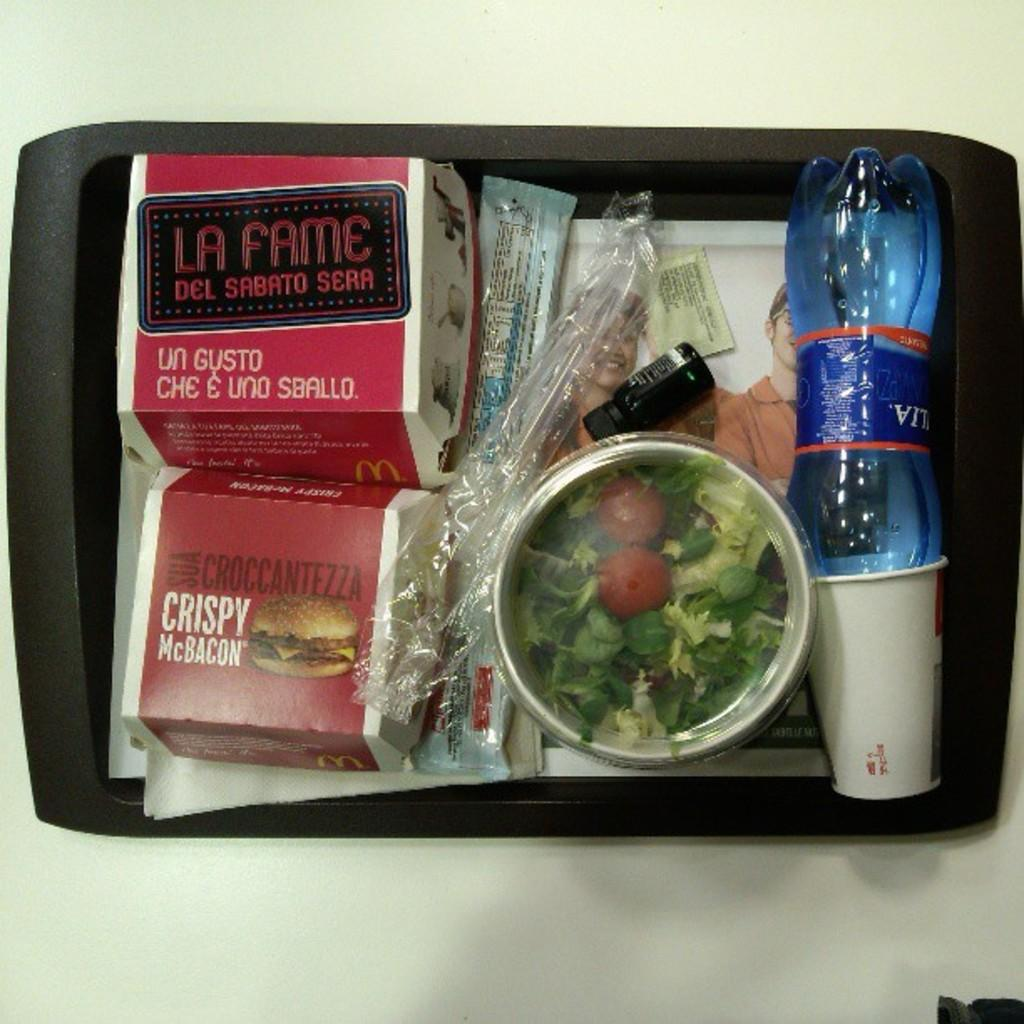Provide a one-sentence caption for the provided image. a lunch tray with food including salad, bottled water, LA FAME DEL SABATO SERA AND CRISPY McBacon. 